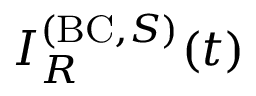<formula> <loc_0><loc_0><loc_500><loc_500>I _ { R } ^ { ( B C , S ) } ( t )</formula> 